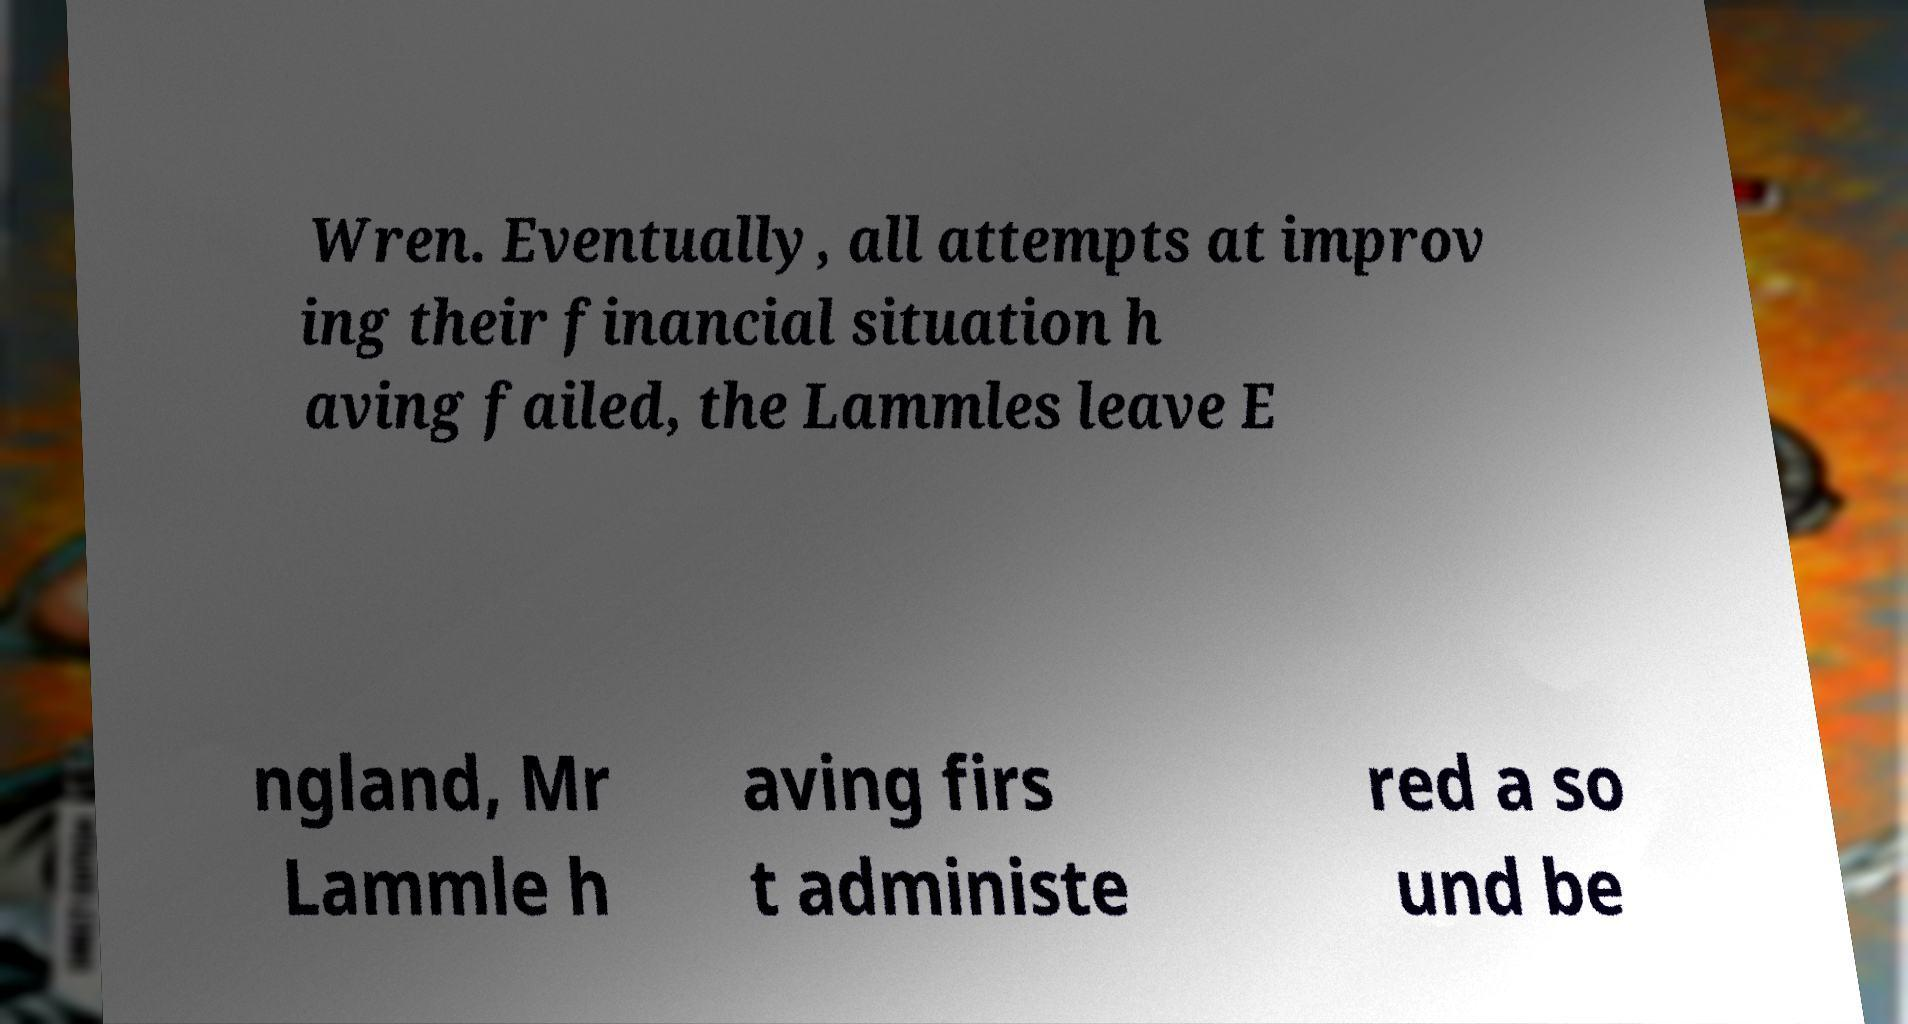Please read and relay the text visible in this image. What does it say? Wren. Eventually, all attempts at improv ing their financial situation h aving failed, the Lammles leave E ngland, Mr Lammle h aving firs t administe red a so und be 